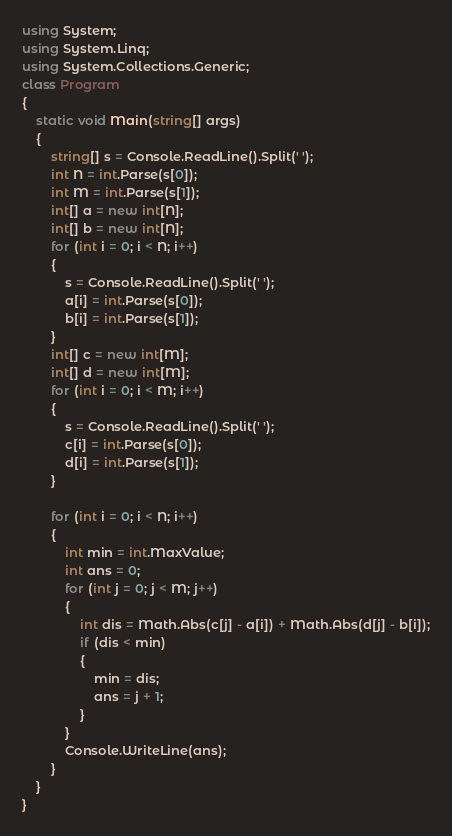Convert code to text. <code><loc_0><loc_0><loc_500><loc_500><_C#_>using System;
using System.Linq;
using System.Collections.Generic;
class Program
{
    static void Main(string[] args)
    {
        string[] s = Console.ReadLine().Split(' ');
        int N = int.Parse(s[0]);
        int M = int.Parse(s[1]);
        int[] a = new int[N];
        int[] b = new int[N];
        for (int i = 0; i < N; i++)
        {
            s = Console.ReadLine().Split(' ');
            a[i] = int.Parse(s[0]);
            b[i] = int.Parse(s[1]);
        }
        int[] c = new int[M];
        int[] d = new int[M];
        for (int i = 0; i < M; i++)
        {
            s = Console.ReadLine().Split(' ');
            c[i] = int.Parse(s[0]);
            d[i] = int.Parse(s[1]);
        }

        for (int i = 0; i < N; i++)
        {
            int min = int.MaxValue;
            int ans = 0;
            for (int j = 0; j < M; j++)
            {
                int dis = Math.Abs(c[j] - a[i]) + Math.Abs(d[j] - b[i]);
                if (dis < min)
                {
                    min = dis;
                    ans = j + 1;
                }
            }
            Console.WriteLine(ans);
        }
    }
}
</code> 